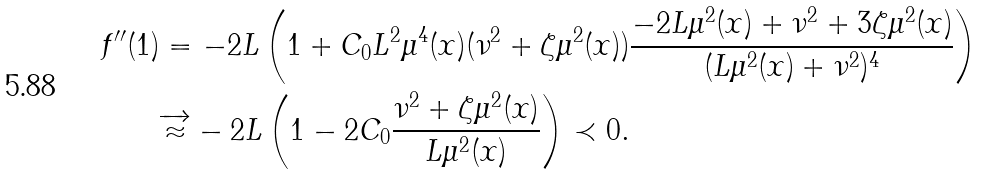<formula> <loc_0><loc_0><loc_500><loc_500>f ^ { \prime \prime } ( 1 ) & = - 2 L \left ( 1 + C _ { 0 } L ^ { 2 } \mu ^ { 4 } ( { x } ) ( \nu ^ { 2 } + \zeta \mu ^ { 2 } ( { x } ) ) \frac { - 2 L \mu ^ { 2 } ( { x } ) + \nu ^ { 2 } + 3 \zeta \mu ^ { 2 } ( { x } ) } { ( L \mu ^ { 2 } ( { x } ) + \nu ^ { 2 } ) ^ { 4 } } \right ) \\ & \overrightarrow { \approx } - 2 L \left ( 1 - 2 C _ { 0 } \frac { \nu ^ { 2 } + \zeta \mu ^ { 2 } ( { x } ) } { L \mu ^ { 2 } ( { x } ) } \right ) \prec 0 .</formula> 